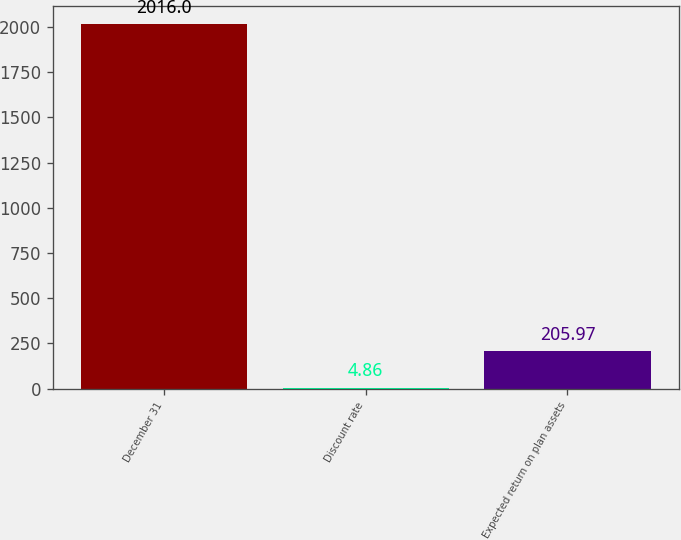Convert chart to OTSL. <chart><loc_0><loc_0><loc_500><loc_500><bar_chart><fcel>December 31<fcel>Discount rate<fcel>Expected return on plan assets<nl><fcel>2016<fcel>4.86<fcel>205.97<nl></chart> 